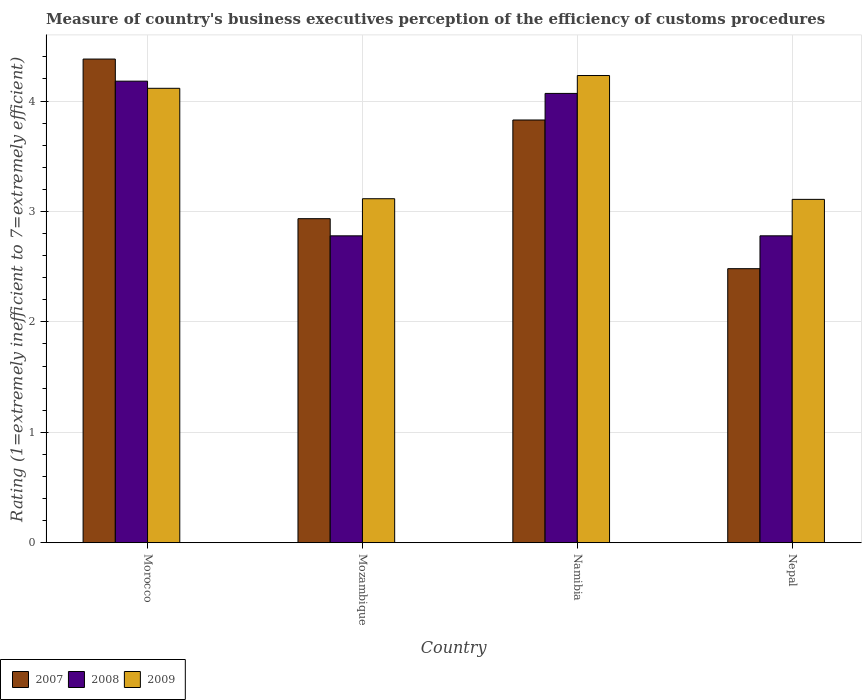How many groups of bars are there?
Make the answer very short. 4. Are the number of bars per tick equal to the number of legend labels?
Make the answer very short. Yes. Are the number of bars on each tick of the X-axis equal?
Give a very brief answer. Yes. What is the label of the 4th group of bars from the left?
Offer a very short reply. Nepal. In how many cases, is the number of bars for a given country not equal to the number of legend labels?
Offer a very short reply. 0. What is the rating of the efficiency of customs procedure in 2009 in Nepal?
Provide a succinct answer. 3.11. Across all countries, what is the maximum rating of the efficiency of customs procedure in 2007?
Your response must be concise. 4.38. Across all countries, what is the minimum rating of the efficiency of customs procedure in 2009?
Make the answer very short. 3.11. In which country was the rating of the efficiency of customs procedure in 2009 maximum?
Your answer should be compact. Namibia. In which country was the rating of the efficiency of customs procedure in 2008 minimum?
Ensure brevity in your answer.  Mozambique. What is the total rating of the efficiency of customs procedure in 2007 in the graph?
Your answer should be compact. 13.63. What is the difference between the rating of the efficiency of customs procedure in 2008 in Morocco and that in Nepal?
Ensure brevity in your answer.  1.4. What is the difference between the rating of the efficiency of customs procedure in 2008 in Mozambique and the rating of the efficiency of customs procedure in 2007 in Morocco?
Your response must be concise. -1.6. What is the average rating of the efficiency of customs procedure in 2007 per country?
Offer a terse response. 3.41. What is the difference between the rating of the efficiency of customs procedure of/in 2009 and rating of the efficiency of customs procedure of/in 2007 in Mozambique?
Give a very brief answer. 0.18. What is the ratio of the rating of the efficiency of customs procedure in 2007 in Morocco to that in Namibia?
Your response must be concise. 1.14. What is the difference between the highest and the second highest rating of the efficiency of customs procedure in 2007?
Your answer should be very brief. -0.89. What is the difference between the highest and the lowest rating of the efficiency of customs procedure in 2007?
Provide a succinct answer. 1.9. In how many countries, is the rating of the efficiency of customs procedure in 2007 greater than the average rating of the efficiency of customs procedure in 2007 taken over all countries?
Give a very brief answer. 2. Is the sum of the rating of the efficiency of customs procedure in 2008 in Morocco and Mozambique greater than the maximum rating of the efficiency of customs procedure in 2007 across all countries?
Your answer should be compact. Yes. What does the 1st bar from the right in Nepal represents?
Your answer should be very brief. 2009. How many bars are there?
Offer a very short reply. 12. Are the values on the major ticks of Y-axis written in scientific E-notation?
Offer a very short reply. No. How are the legend labels stacked?
Give a very brief answer. Horizontal. What is the title of the graph?
Make the answer very short. Measure of country's business executives perception of the efficiency of customs procedures. Does "1999" appear as one of the legend labels in the graph?
Offer a terse response. No. What is the label or title of the X-axis?
Offer a terse response. Country. What is the label or title of the Y-axis?
Provide a short and direct response. Rating (1=extremely inefficient to 7=extremely efficient). What is the Rating (1=extremely inefficient to 7=extremely efficient) of 2007 in Morocco?
Give a very brief answer. 4.38. What is the Rating (1=extremely inefficient to 7=extremely efficient) in 2008 in Morocco?
Provide a succinct answer. 4.18. What is the Rating (1=extremely inefficient to 7=extremely efficient) in 2009 in Morocco?
Provide a succinct answer. 4.12. What is the Rating (1=extremely inefficient to 7=extremely efficient) of 2007 in Mozambique?
Offer a very short reply. 2.93. What is the Rating (1=extremely inefficient to 7=extremely efficient) of 2008 in Mozambique?
Offer a very short reply. 2.78. What is the Rating (1=extremely inefficient to 7=extremely efficient) in 2009 in Mozambique?
Give a very brief answer. 3.12. What is the Rating (1=extremely inefficient to 7=extremely efficient) of 2007 in Namibia?
Your answer should be very brief. 3.83. What is the Rating (1=extremely inefficient to 7=extremely efficient) of 2008 in Namibia?
Provide a short and direct response. 4.07. What is the Rating (1=extremely inefficient to 7=extremely efficient) of 2009 in Namibia?
Provide a short and direct response. 4.23. What is the Rating (1=extremely inefficient to 7=extremely efficient) of 2007 in Nepal?
Provide a succinct answer. 2.48. What is the Rating (1=extremely inefficient to 7=extremely efficient) of 2008 in Nepal?
Your answer should be compact. 2.78. What is the Rating (1=extremely inefficient to 7=extremely efficient) of 2009 in Nepal?
Keep it short and to the point. 3.11. Across all countries, what is the maximum Rating (1=extremely inefficient to 7=extremely efficient) of 2007?
Ensure brevity in your answer.  4.38. Across all countries, what is the maximum Rating (1=extremely inefficient to 7=extremely efficient) in 2008?
Ensure brevity in your answer.  4.18. Across all countries, what is the maximum Rating (1=extremely inefficient to 7=extremely efficient) of 2009?
Offer a very short reply. 4.23. Across all countries, what is the minimum Rating (1=extremely inefficient to 7=extremely efficient) in 2007?
Provide a succinct answer. 2.48. Across all countries, what is the minimum Rating (1=extremely inefficient to 7=extremely efficient) in 2008?
Offer a very short reply. 2.78. Across all countries, what is the minimum Rating (1=extremely inefficient to 7=extremely efficient) in 2009?
Ensure brevity in your answer.  3.11. What is the total Rating (1=extremely inefficient to 7=extremely efficient) in 2007 in the graph?
Provide a short and direct response. 13.63. What is the total Rating (1=extremely inefficient to 7=extremely efficient) of 2008 in the graph?
Give a very brief answer. 13.81. What is the total Rating (1=extremely inefficient to 7=extremely efficient) in 2009 in the graph?
Offer a terse response. 14.57. What is the difference between the Rating (1=extremely inefficient to 7=extremely efficient) in 2007 in Morocco and that in Mozambique?
Offer a very short reply. 1.45. What is the difference between the Rating (1=extremely inefficient to 7=extremely efficient) of 2008 in Morocco and that in Mozambique?
Provide a short and direct response. 1.4. What is the difference between the Rating (1=extremely inefficient to 7=extremely efficient) in 2007 in Morocco and that in Namibia?
Your response must be concise. 0.55. What is the difference between the Rating (1=extremely inefficient to 7=extremely efficient) of 2008 in Morocco and that in Namibia?
Offer a very short reply. 0.11. What is the difference between the Rating (1=extremely inefficient to 7=extremely efficient) in 2009 in Morocco and that in Namibia?
Your answer should be very brief. -0.12. What is the difference between the Rating (1=extremely inefficient to 7=extremely efficient) in 2007 in Morocco and that in Nepal?
Keep it short and to the point. 1.9. What is the difference between the Rating (1=extremely inefficient to 7=extremely efficient) in 2008 in Morocco and that in Nepal?
Offer a terse response. 1.4. What is the difference between the Rating (1=extremely inefficient to 7=extremely efficient) in 2009 in Morocco and that in Nepal?
Offer a very short reply. 1.01. What is the difference between the Rating (1=extremely inefficient to 7=extremely efficient) in 2007 in Mozambique and that in Namibia?
Keep it short and to the point. -0.89. What is the difference between the Rating (1=extremely inefficient to 7=extremely efficient) of 2008 in Mozambique and that in Namibia?
Provide a succinct answer. -1.29. What is the difference between the Rating (1=extremely inefficient to 7=extremely efficient) in 2009 in Mozambique and that in Namibia?
Your answer should be very brief. -1.12. What is the difference between the Rating (1=extremely inefficient to 7=extremely efficient) of 2007 in Mozambique and that in Nepal?
Give a very brief answer. 0.45. What is the difference between the Rating (1=extremely inefficient to 7=extremely efficient) of 2008 in Mozambique and that in Nepal?
Provide a short and direct response. -0. What is the difference between the Rating (1=extremely inefficient to 7=extremely efficient) of 2009 in Mozambique and that in Nepal?
Your response must be concise. 0.01. What is the difference between the Rating (1=extremely inefficient to 7=extremely efficient) in 2007 in Namibia and that in Nepal?
Ensure brevity in your answer.  1.35. What is the difference between the Rating (1=extremely inefficient to 7=extremely efficient) of 2008 in Namibia and that in Nepal?
Your answer should be very brief. 1.29. What is the difference between the Rating (1=extremely inefficient to 7=extremely efficient) of 2009 in Namibia and that in Nepal?
Provide a succinct answer. 1.12. What is the difference between the Rating (1=extremely inefficient to 7=extremely efficient) of 2007 in Morocco and the Rating (1=extremely inefficient to 7=extremely efficient) of 2008 in Mozambique?
Give a very brief answer. 1.6. What is the difference between the Rating (1=extremely inefficient to 7=extremely efficient) of 2007 in Morocco and the Rating (1=extremely inefficient to 7=extremely efficient) of 2009 in Mozambique?
Keep it short and to the point. 1.26. What is the difference between the Rating (1=extremely inefficient to 7=extremely efficient) of 2008 in Morocco and the Rating (1=extremely inefficient to 7=extremely efficient) of 2009 in Mozambique?
Provide a short and direct response. 1.06. What is the difference between the Rating (1=extremely inefficient to 7=extremely efficient) of 2007 in Morocco and the Rating (1=extremely inefficient to 7=extremely efficient) of 2008 in Namibia?
Your answer should be very brief. 0.31. What is the difference between the Rating (1=extremely inefficient to 7=extremely efficient) in 2007 in Morocco and the Rating (1=extremely inefficient to 7=extremely efficient) in 2009 in Namibia?
Ensure brevity in your answer.  0.15. What is the difference between the Rating (1=extremely inefficient to 7=extremely efficient) of 2008 in Morocco and the Rating (1=extremely inefficient to 7=extremely efficient) of 2009 in Namibia?
Offer a very short reply. -0.05. What is the difference between the Rating (1=extremely inefficient to 7=extremely efficient) of 2007 in Morocco and the Rating (1=extremely inefficient to 7=extremely efficient) of 2008 in Nepal?
Give a very brief answer. 1.6. What is the difference between the Rating (1=extremely inefficient to 7=extremely efficient) in 2007 in Morocco and the Rating (1=extremely inefficient to 7=extremely efficient) in 2009 in Nepal?
Give a very brief answer. 1.27. What is the difference between the Rating (1=extremely inefficient to 7=extremely efficient) of 2008 in Morocco and the Rating (1=extremely inefficient to 7=extremely efficient) of 2009 in Nepal?
Keep it short and to the point. 1.07. What is the difference between the Rating (1=extremely inefficient to 7=extremely efficient) in 2007 in Mozambique and the Rating (1=extremely inefficient to 7=extremely efficient) in 2008 in Namibia?
Your answer should be compact. -1.13. What is the difference between the Rating (1=extremely inefficient to 7=extremely efficient) in 2007 in Mozambique and the Rating (1=extremely inefficient to 7=extremely efficient) in 2009 in Namibia?
Offer a terse response. -1.3. What is the difference between the Rating (1=extremely inefficient to 7=extremely efficient) of 2008 in Mozambique and the Rating (1=extremely inefficient to 7=extremely efficient) of 2009 in Namibia?
Keep it short and to the point. -1.45. What is the difference between the Rating (1=extremely inefficient to 7=extremely efficient) of 2007 in Mozambique and the Rating (1=extremely inefficient to 7=extremely efficient) of 2008 in Nepal?
Offer a terse response. 0.16. What is the difference between the Rating (1=extremely inefficient to 7=extremely efficient) in 2007 in Mozambique and the Rating (1=extremely inefficient to 7=extremely efficient) in 2009 in Nepal?
Provide a succinct answer. -0.17. What is the difference between the Rating (1=extremely inefficient to 7=extremely efficient) in 2008 in Mozambique and the Rating (1=extremely inefficient to 7=extremely efficient) in 2009 in Nepal?
Offer a very short reply. -0.33. What is the difference between the Rating (1=extremely inefficient to 7=extremely efficient) of 2007 in Namibia and the Rating (1=extremely inefficient to 7=extremely efficient) of 2008 in Nepal?
Your response must be concise. 1.05. What is the difference between the Rating (1=extremely inefficient to 7=extremely efficient) of 2007 in Namibia and the Rating (1=extremely inefficient to 7=extremely efficient) of 2009 in Nepal?
Your response must be concise. 0.72. What is the difference between the Rating (1=extremely inefficient to 7=extremely efficient) of 2008 in Namibia and the Rating (1=extremely inefficient to 7=extremely efficient) of 2009 in Nepal?
Give a very brief answer. 0.96. What is the average Rating (1=extremely inefficient to 7=extremely efficient) in 2007 per country?
Keep it short and to the point. 3.41. What is the average Rating (1=extremely inefficient to 7=extremely efficient) in 2008 per country?
Offer a very short reply. 3.45. What is the average Rating (1=extremely inefficient to 7=extremely efficient) in 2009 per country?
Offer a terse response. 3.64. What is the difference between the Rating (1=extremely inefficient to 7=extremely efficient) in 2007 and Rating (1=extremely inefficient to 7=extremely efficient) in 2008 in Morocco?
Give a very brief answer. 0.2. What is the difference between the Rating (1=extremely inefficient to 7=extremely efficient) in 2007 and Rating (1=extremely inefficient to 7=extremely efficient) in 2009 in Morocco?
Ensure brevity in your answer.  0.26. What is the difference between the Rating (1=extremely inefficient to 7=extremely efficient) in 2008 and Rating (1=extremely inefficient to 7=extremely efficient) in 2009 in Morocco?
Your answer should be very brief. 0.06. What is the difference between the Rating (1=extremely inefficient to 7=extremely efficient) of 2007 and Rating (1=extremely inefficient to 7=extremely efficient) of 2008 in Mozambique?
Your answer should be compact. 0.16. What is the difference between the Rating (1=extremely inefficient to 7=extremely efficient) in 2007 and Rating (1=extremely inefficient to 7=extremely efficient) in 2009 in Mozambique?
Your response must be concise. -0.18. What is the difference between the Rating (1=extremely inefficient to 7=extremely efficient) in 2008 and Rating (1=extremely inefficient to 7=extremely efficient) in 2009 in Mozambique?
Provide a succinct answer. -0.34. What is the difference between the Rating (1=extremely inefficient to 7=extremely efficient) of 2007 and Rating (1=extremely inefficient to 7=extremely efficient) of 2008 in Namibia?
Your response must be concise. -0.24. What is the difference between the Rating (1=extremely inefficient to 7=extremely efficient) of 2007 and Rating (1=extremely inefficient to 7=extremely efficient) of 2009 in Namibia?
Your response must be concise. -0.4. What is the difference between the Rating (1=extremely inefficient to 7=extremely efficient) in 2008 and Rating (1=extremely inefficient to 7=extremely efficient) in 2009 in Namibia?
Make the answer very short. -0.16. What is the difference between the Rating (1=extremely inefficient to 7=extremely efficient) in 2007 and Rating (1=extremely inefficient to 7=extremely efficient) in 2008 in Nepal?
Your answer should be very brief. -0.3. What is the difference between the Rating (1=extremely inefficient to 7=extremely efficient) in 2007 and Rating (1=extremely inefficient to 7=extremely efficient) in 2009 in Nepal?
Keep it short and to the point. -0.63. What is the difference between the Rating (1=extremely inefficient to 7=extremely efficient) of 2008 and Rating (1=extremely inefficient to 7=extremely efficient) of 2009 in Nepal?
Provide a short and direct response. -0.33. What is the ratio of the Rating (1=extremely inefficient to 7=extremely efficient) in 2007 in Morocco to that in Mozambique?
Ensure brevity in your answer.  1.49. What is the ratio of the Rating (1=extremely inefficient to 7=extremely efficient) in 2008 in Morocco to that in Mozambique?
Your answer should be very brief. 1.5. What is the ratio of the Rating (1=extremely inefficient to 7=extremely efficient) of 2009 in Morocco to that in Mozambique?
Your answer should be very brief. 1.32. What is the ratio of the Rating (1=extremely inefficient to 7=extremely efficient) of 2007 in Morocco to that in Namibia?
Provide a short and direct response. 1.14. What is the ratio of the Rating (1=extremely inefficient to 7=extremely efficient) in 2008 in Morocco to that in Namibia?
Ensure brevity in your answer.  1.03. What is the ratio of the Rating (1=extremely inefficient to 7=extremely efficient) of 2009 in Morocco to that in Namibia?
Your answer should be very brief. 0.97. What is the ratio of the Rating (1=extremely inefficient to 7=extremely efficient) in 2007 in Morocco to that in Nepal?
Ensure brevity in your answer.  1.76. What is the ratio of the Rating (1=extremely inefficient to 7=extremely efficient) in 2008 in Morocco to that in Nepal?
Provide a succinct answer. 1.5. What is the ratio of the Rating (1=extremely inefficient to 7=extremely efficient) in 2009 in Morocco to that in Nepal?
Provide a short and direct response. 1.32. What is the ratio of the Rating (1=extremely inefficient to 7=extremely efficient) in 2007 in Mozambique to that in Namibia?
Provide a succinct answer. 0.77. What is the ratio of the Rating (1=extremely inefficient to 7=extremely efficient) in 2008 in Mozambique to that in Namibia?
Offer a very short reply. 0.68. What is the ratio of the Rating (1=extremely inefficient to 7=extremely efficient) of 2009 in Mozambique to that in Namibia?
Offer a very short reply. 0.74. What is the ratio of the Rating (1=extremely inefficient to 7=extremely efficient) in 2007 in Mozambique to that in Nepal?
Give a very brief answer. 1.18. What is the ratio of the Rating (1=extremely inefficient to 7=extremely efficient) of 2008 in Mozambique to that in Nepal?
Your answer should be compact. 1. What is the ratio of the Rating (1=extremely inefficient to 7=extremely efficient) in 2009 in Mozambique to that in Nepal?
Give a very brief answer. 1. What is the ratio of the Rating (1=extremely inefficient to 7=extremely efficient) of 2007 in Namibia to that in Nepal?
Provide a short and direct response. 1.54. What is the ratio of the Rating (1=extremely inefficient to 7=extremely efficient) in 2008 in Namibia to that in Nepal?
Ensure brevity in your answer.  1.46. What is the ratio of the Rating (1=extremely inefficient to 7=extremely efficient) in 2009 in Namibia to that in Nepal?
Your response must be concise. 1.36. What is the difference between the highest and the second highest Rating (1=extremely inefficient to 7=extremely efficient) in 2007?
Make the answer very short. 0.55. What is the difference between the highest and the second highest Rating (1=extremely inefficient to 7=extremely efficient) in 2008?
Provide a short and direct response. 0.11. What is the difference between the highest and the second highest Rating (1=extremely inefficient to 7=extremely efficient) in 2009?
Provide a succinct answer. 0.12. What is the difference between the highest and the lowest Rating (1=extremely inefficient to 7=extremely efficient) of 2007?
Make the answer very short. 1.9. What is the difference between the highest and the lowest Rating (1=extremely inefficient to 7=extremely efficient) of 2008?
Keep it short and to the point. 1.4. What is the difference between the highest and the lowest Rating (1=extremely inefficient to 7=extremely efficient) of 2009?
Offer a terse response. 1.12. 